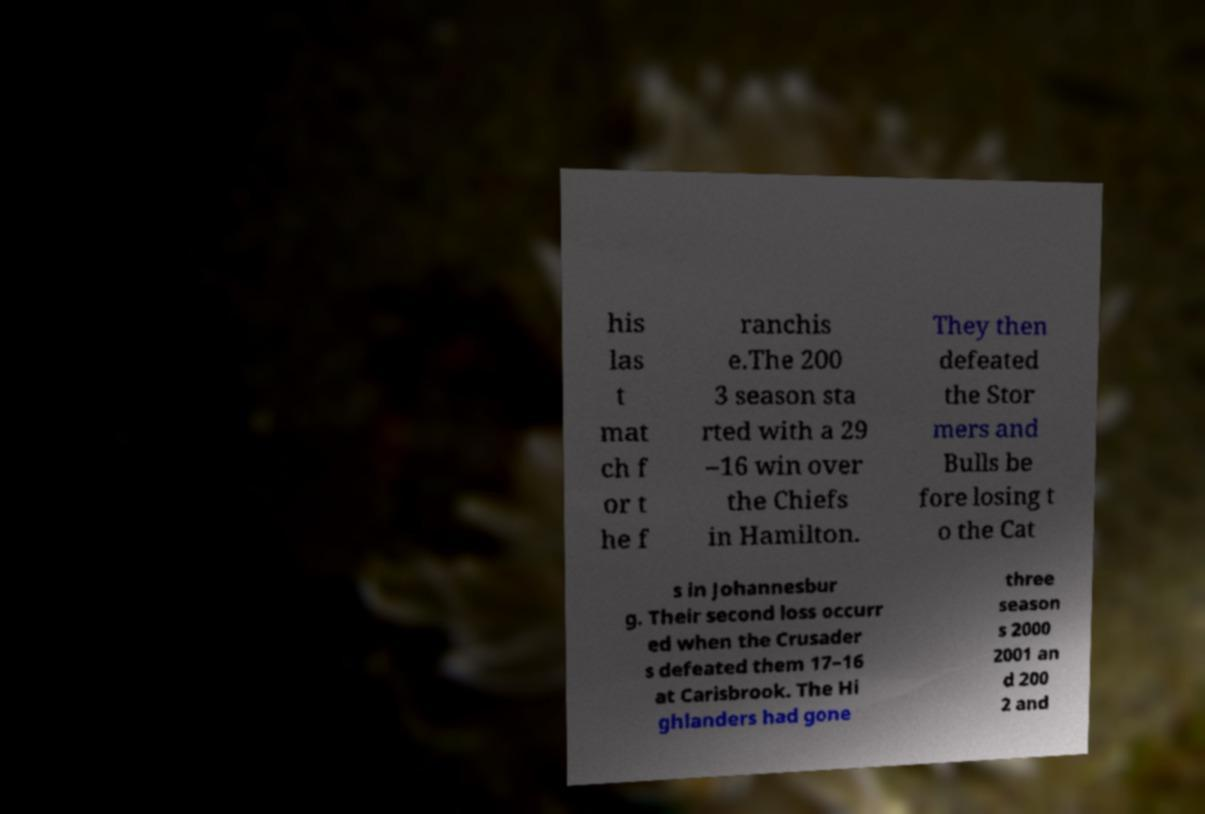Please read and relay the text visible in this image. What does it say? his las t mat ch f or t he f ranchis e.The 200 3 season sta rted with a 29 –16 win over the Chiefs in Hamilton. They then defeated the Stor mers and Bulls be fore losing t o the Cat s in Johannesbur g. Their second loss occurr ed when the Crusader s defeated them 17–16 at Carisbrook. The Hi ghlanders had gone three season s 2000 2001 an d 200 2 and 